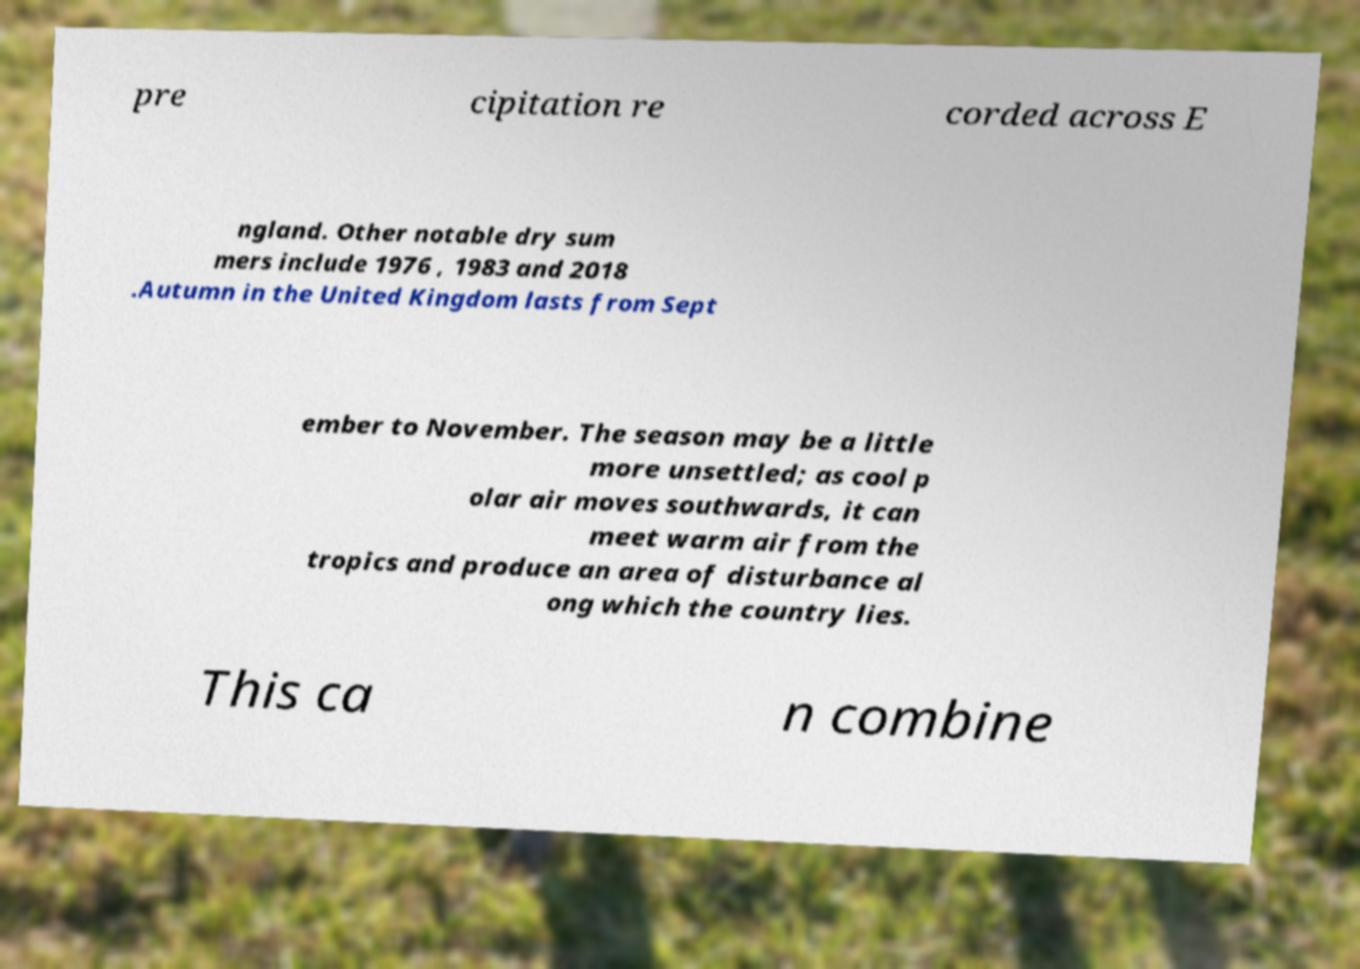Could you extract and type out the text from this image? pre cipitation re corded across E ngland. Other notable dry sum mers include 1976 , 1983 and 2018 .Autumn in the United Kingdom lasts from Sept ember to November. The season may be a little more unsettled; as cool p olar air moves southwards, it can meet warm air from the tropics and produce an area of disturbance al ong which the country lies. This ca n combine 